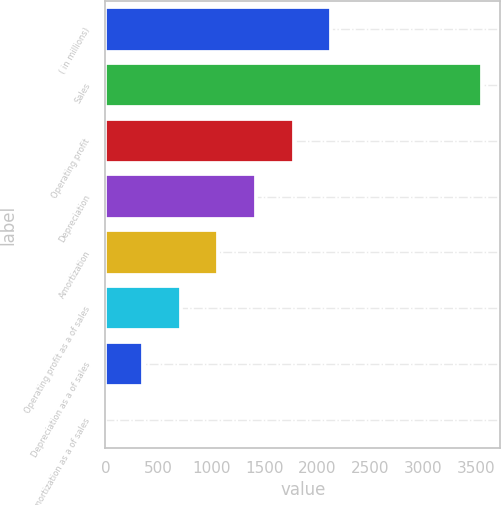Convert chart to OTSL. <chart><loc_0><loc_0><loc_500><loc_500><bar_chart><fcel>( in millions)<fcel>Sales<fcel>Operating profit<fcel>Depreciation<fcel>Amortization<fcel>Operating profit as a of sales<fcel>Depreciation as a of sales<fcel>Amortization as a of sales<nl><fcel>2128.78<fcel>3547.3<fcel>1774.15<fcel>1419.52<fcel>1064.89<fcel>710.26<fcel>355.63<fcel>1<nl></chart> 